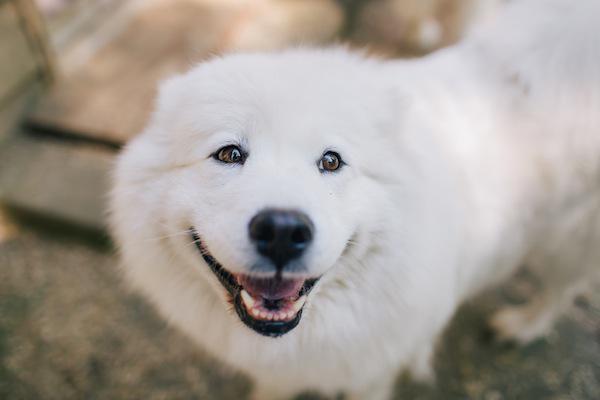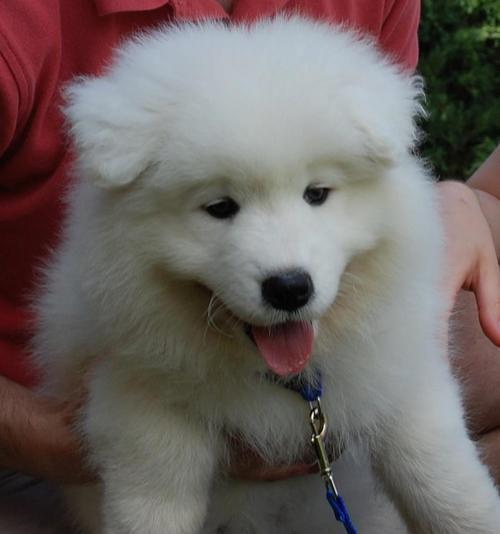The first image is the image on the left, the second image is the image on the right. For the images displayed, is the sentence "The combined images include two white dogs with smiling opened mouths showing pink tongues." factually correct? Answer yes or no. Yes. The first image is the image on the left, the second image is the image on the right. For the images shown, is this caption "The right image contains at least one white dog with its tongue exposed." true? Answer yes or no. Yes. 